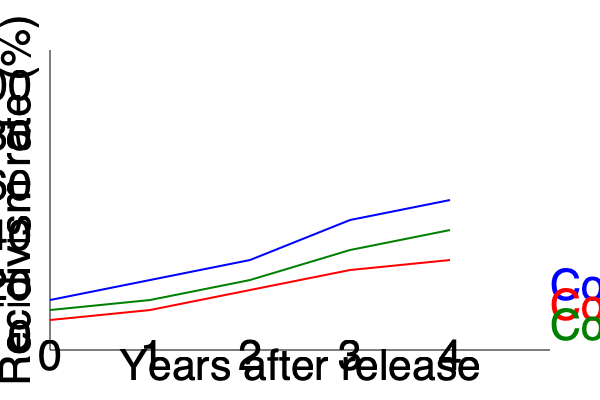Based on the line graph showing recidivism rates over 4 years for three different countries, which country has the lowest recidivism rate at the 4-year mark, and what does this suggest about the effectiveness of their prison system? To answer this question, we need to follow these steps:

1. Identify the recidivism rates for each country at the 4-year mark:
   - Country A (blue line): Approximately 40%
   - Country B (red line): Approximately 48%
   - Country C (green line): Approximately 44%

2. Compare the rates to determine the lowest:
   Country A has the lowest rate at 40%.

3. Interpret the results:
   The lower recidivism rate suggests that Country A's prison system might be more effective at reducing repeat offenses. However, this interpretation should be made cautiously, as:

   a) The difference between countries is relatively small (8% between highest and lowest).
   b) Recidivism rates are influenced by many factors beyond the prison system, such as societal support, economic conditions, and cultural norms.
   c) The graph doesn't show other important metrics like crime rates, prison population, or rehabilitation programs.

4. Consider the persona's perspective:
   As a socio-political commentator who dismisses the cultural impacts of incarceration, the focus would likely be on the quantitative differences rather than qualitative factors. The persona might argue that the small differences in recidivism rates indicate that cultural factors have minimal impact on post-release outcomes.
Answer: Country A; suggests marginally better effectiveness, but differences are small and other factors should be considered. 